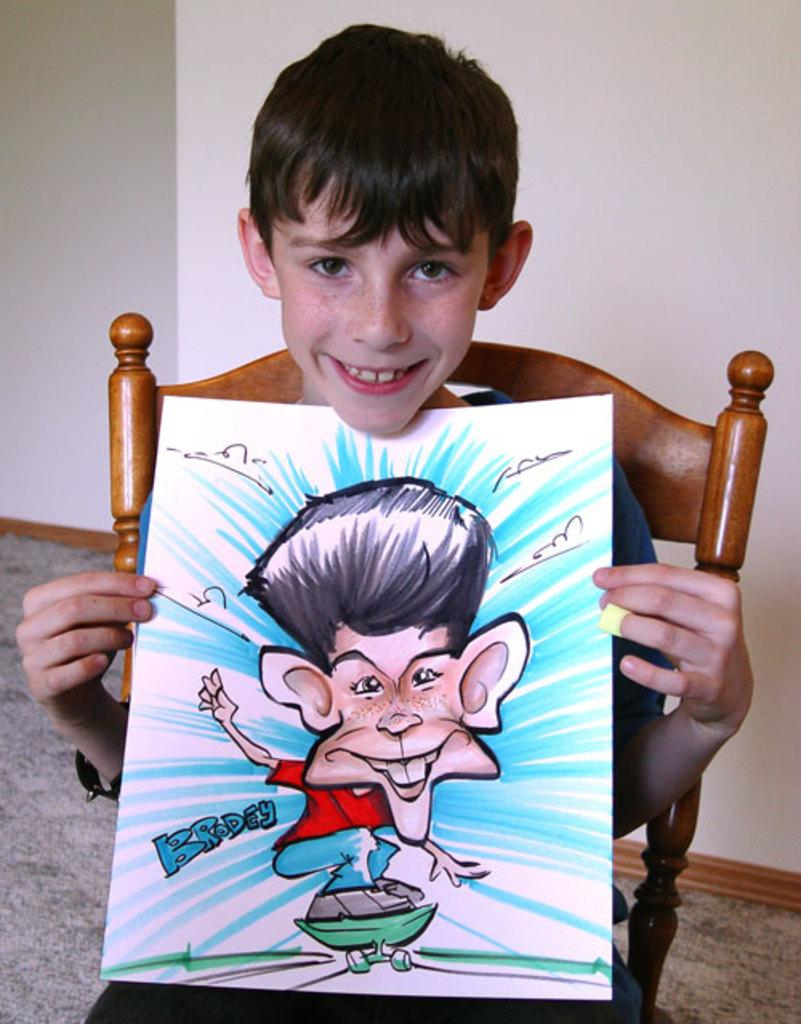What is the main subject of the image? The main subject of the image is a kid. What is the kid doing in the image? The kid is sitting on a chair and holding a paper with his hands. What can be seen in the background of the image? There is a wall in the background of the image. What type of train can be seen passing by in the image? There is no train present in the image; it only features a kid sitting on a chair and holding a paper. How many stems are visible in the image? There are no stems present in the image. 